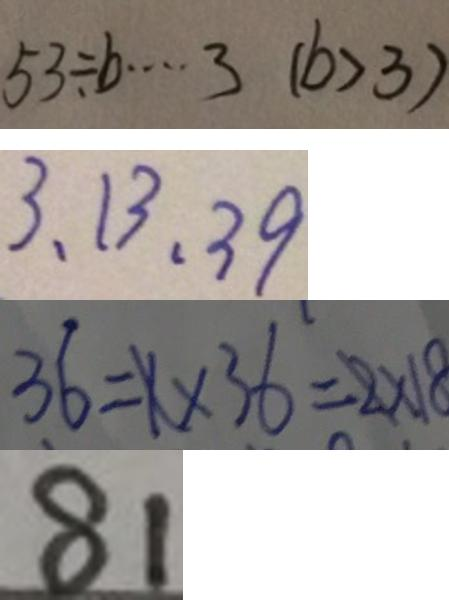Convert formula to latex. <formula><loc_0><loc_0><loc_500><loc_500>5 3 \div b \cdots 3 ( b > 3 ) 
 3 、 1 3 、 3 9 
 3 6 = 1 \times 3 6 = 2 \times 1 8 
 8 1</formula> 